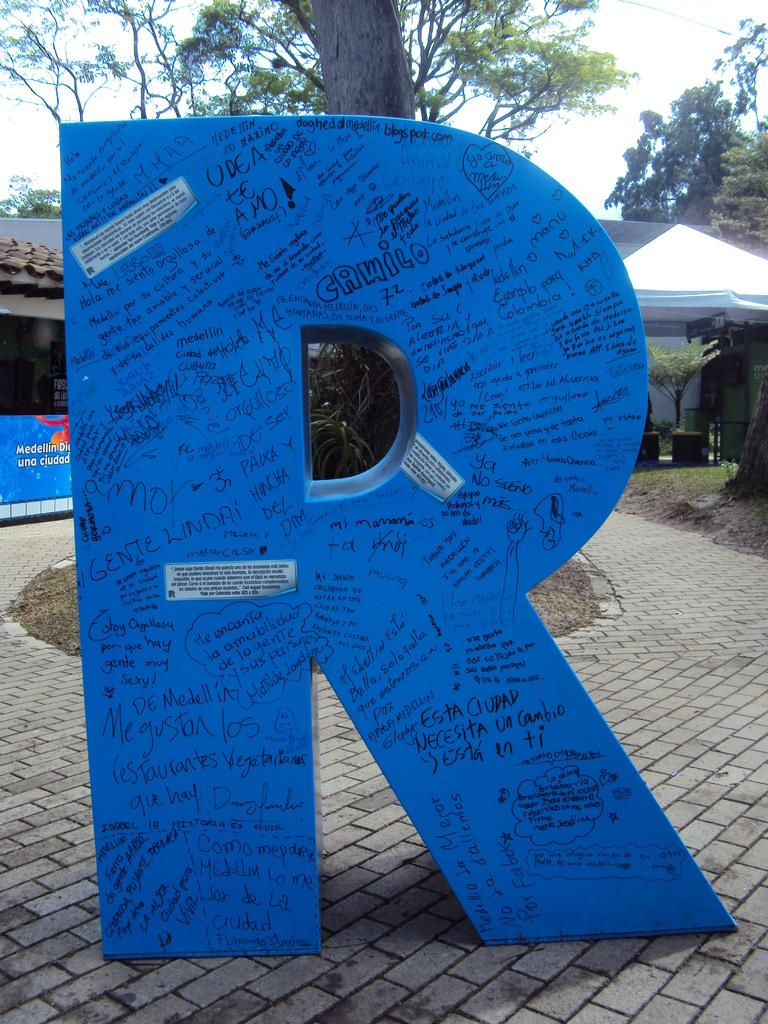What is the main subject of the image? The main subject of the image is a huge structure in the shape of letter "R". Can you describe the color of the structure? The structure is blue in color. What can be seen in the background of the image? There are trees, a house, a banner, and the sky visible in the background of the image. What type of mine is depicted in the image? There is no mine present in the image; it features a huge structure in the shape of letter "R". What belief system is represented by the banner in the image? There is no indication of a specific belief system represented by the banner in the image. 